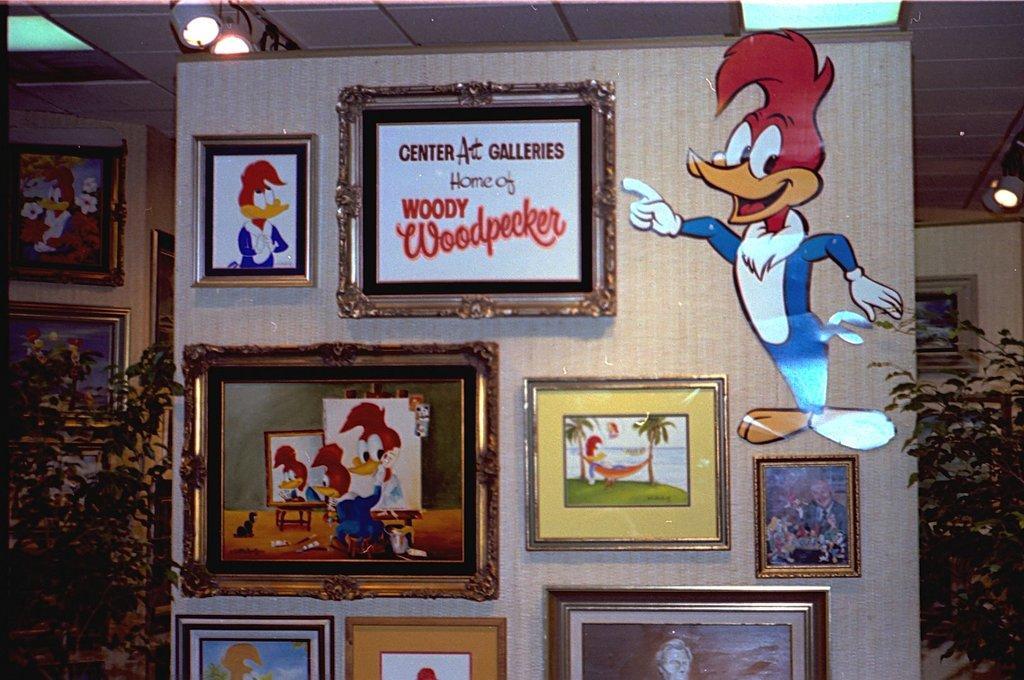Please provide a concise description of this image. In the middle of the image there is a wall, on the wall there are some frames and posters and there are some plants. At the top of the image there is roof and lights. 